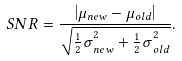<formula> <loc_0><loc_0><loc_500><loc_500>S N R = \frac { \left | \mu _ { n e w } - \mu _ { o l d } \right | } { \sqrt { { \frac { 1 } { 2 } \sigma } _ { n e w } ^ { 2 } + { \frac { 1 } { 2 } \sigma } _ { o l d } ^ { 2 } } } .</formula> 